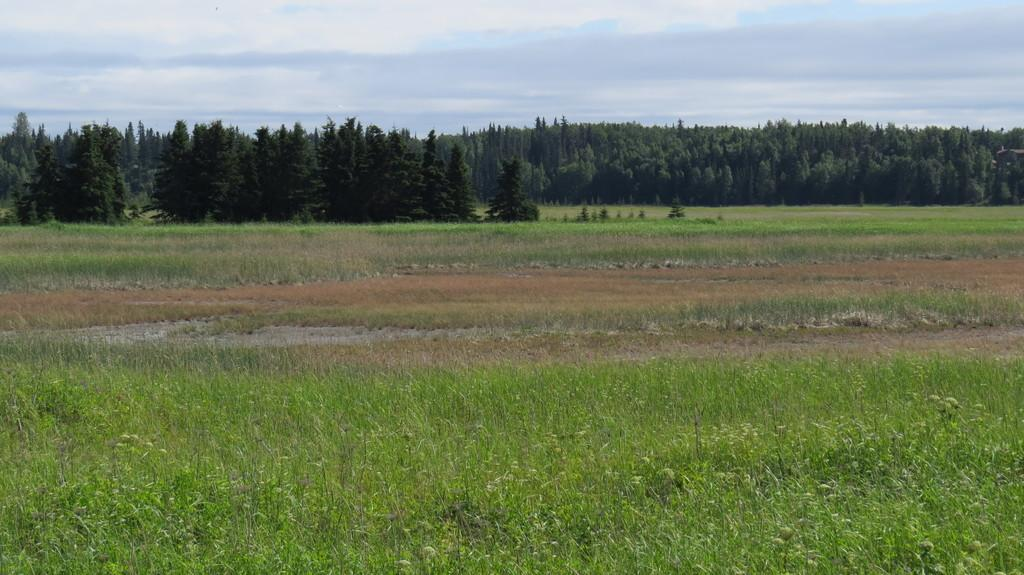What can be seen at the top of the image? The sky is visible towards the top of the image. What is present in the sky? There are clouds in the sky. What type of vegetation is present in the image? There are trees and plants in the image. Where are the plants located in the image? The plants are towards the bottom of the image. How do the giants affect the plants in the image? There are no giants present in the image, so their impact on the plants cannot be determined. 